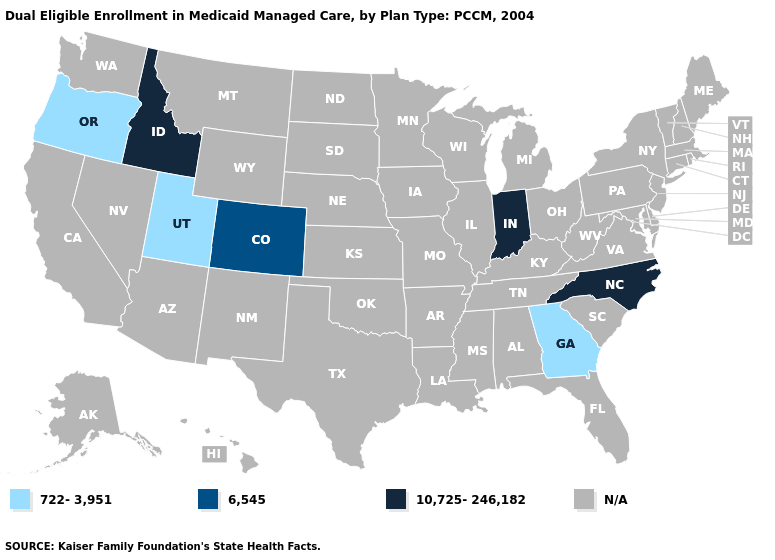Which states hav the highest value in the MidWest?
Short answer required. Indiana. Name the states that have a value in the range 722-3,951?
Write a very short answer. Georgia, Oregon, Utah. What is the value of Illinois?
Answer briefly. N/A. What is the value of Tennessee?
Concise answer only. N/A. What is the value of Georgia?
Concise answer only. 722-3,951. What is the lowest value in states that border Tennessee?
Give a very brief answer. 722-3,951. Does Idaho have the highest value in the USA?
Give a very brief answer. Yes. Which states have the lowest value in the USA?
Answer briefly. Georgia, Oregon, Utah. Among the states that border Kentucky , which have the highest value?
Be succinct. Indiana. How many symbols are there in the legend?
Answer briefly. 4. 